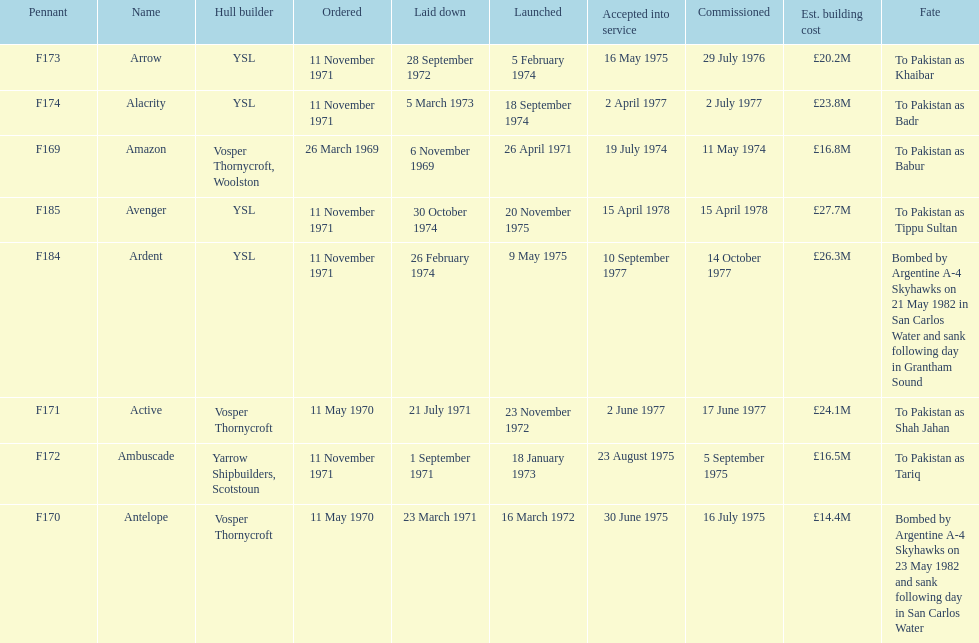What is the last name listed on this chart? Avenger. 